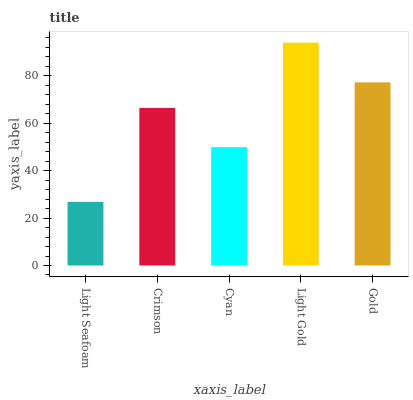Is Light Seafoam the minimum?
Answer yes or no. Yes. Is Light Gold the maximum?
Answer yes or no. Yes. Is Crimson the minimum?
Answer yes or no. No. Is Crimson the maximum?
Answer yes or no. No. Is Crimson greater than Light Seafoam?
Answer yes or no. Yes. Is Light Seafoam less than Crimson?
Answer yes or no. Yes. Is Light Seafoam greater than Crimson?
Answer yes or no. No. Is Crimson less than Light Seafoam?
Answer yes or no. No. Is Crimson the high median?
Answer yes or no. Yes. Is Crimson the low median?
Answer yes or no. Yes. Is Light Gold the high median?
Answer yes or no. No. Is Gold the low median?
Answer yes or no. No. 